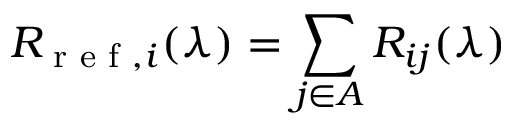Convert formula to latex. <formula><loc_0><loc_0><loc_500><loc_500>R _ { r e f , i } ( \lambda ) = \sum _ { j \in A } R _ { i j } ( \lambda )</formula> 